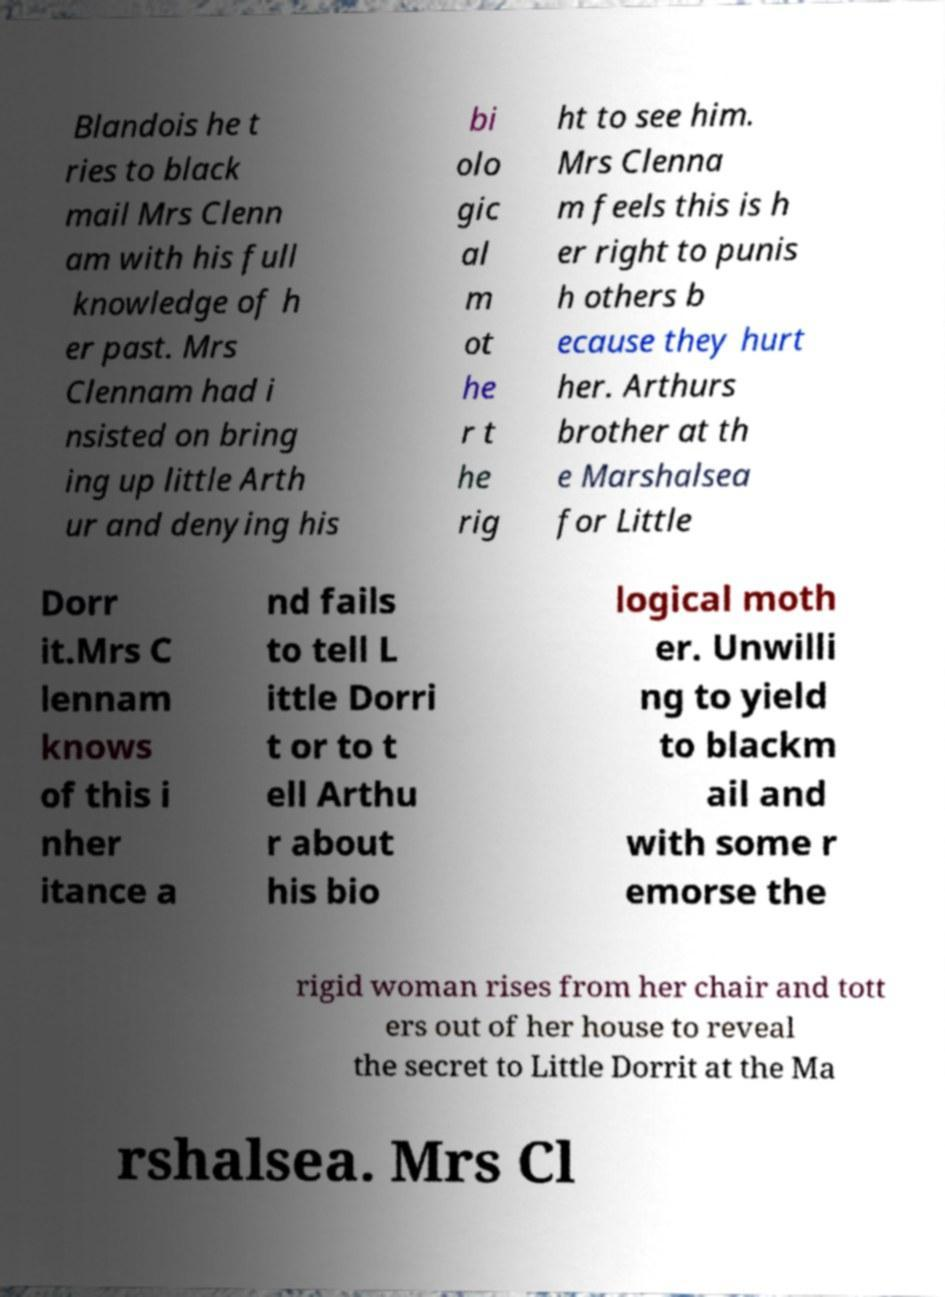Can you accurately transcribe the text from the provided image for me? Blandois he t ries to black mail Mrs Clenn am with his full knowledge of h er past. Mrs Clennam had i nsisted on bring ing up little Arth ur and denying his bi olo gic al m ot he r t he rig ht to see him. Mrs Clenna m feels this is h er right to punis h others b ecause they hurt her. Arthurs brother at th e Marshalsea for Little Dorr it.Mrs C lennam knows of this i nher itance a nd fails to tell L ittle Dorri t or to t ell Arthu r about his bio logical moth er. Unwilli ng to yield to blackm ail and with some r emorse the rigid woman rises from her chair and tott ers out of her house to reveal the secret to Little Dorrit at the Ma rshalsea. Mrs Cl 